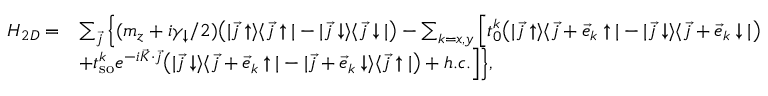<formula> <loc_0><loc_0><loc_500><loc_500>\begin{array} { r l } { H _ { 2 D } = } & { \sum _ { \vec { j } } \left \{ ( m _ { z } + i \gamma _ { \downarrow } / 2 ) \left ( | \vec { j } \uparrow \rangle \langle \vec { j } \uparrow | - | \vec { j } \downarrow \rangle \langle \vec { j } \downarrow | \right ) - \sum _ { k = x , y } \left [ t _ { 0 } ^ { k } \left ( | \vec { j } \uparrow \rangle \langle \vec { j } + \vec { e } _ { k } \uparrow | - | \vec { j } \downarrow \rangle \langle \vec { j } + \vec { e } _ { k } \downarrow | \right ) } \\ & { + t _ { s o } ^ { k } e ^ { - i \vec { K } \cdot \vec { j } } \left ( | \vec { j } \downarrow \rangle \langle \vec { j } + \vec { e } _ { k } \uparrow | - | \vec { j } + \vec { e } _ { k } \downarrow \rangle \langle \vec { j } \uparrow | \right ) + h . c . \right ] \right \} , } \end{array}</formula> 